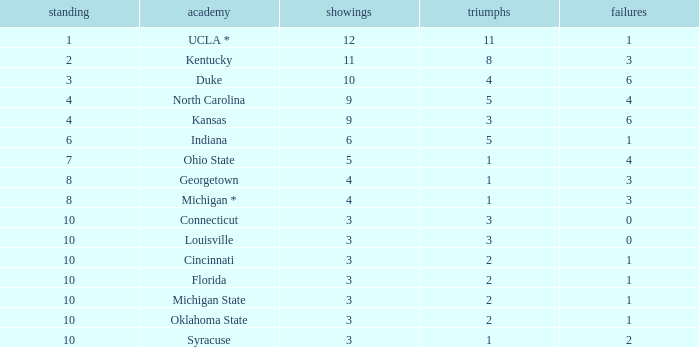Tell me the sum of losses for wins less than 2 and rank of 10 with appearances larger than 3 None. 